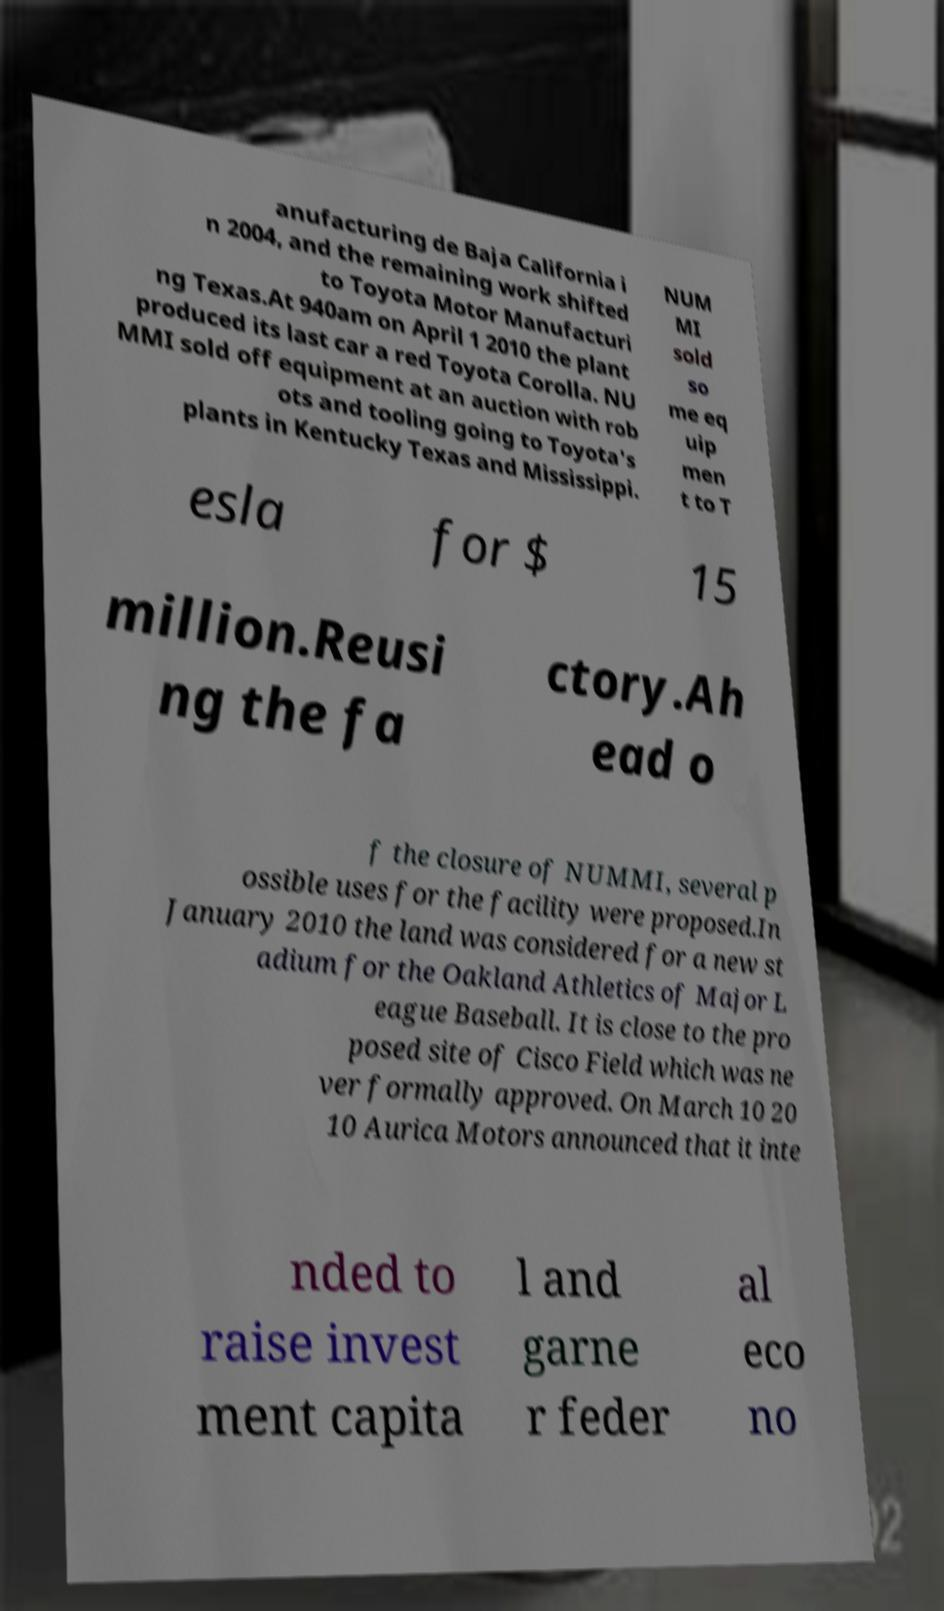Can you accurately transcribe the text from the provided image for me? anufacturing de Baja California i n 2004, and the remaining work shifted to Toyota Motor Manufacturi ng Texas.At 940am on April 1 2010 the plant produced its last car a red Toyota Corolla. NU MMI sold off equipment at an auction with rob ots and tooling going to Toyota's plants in Kentucky Texas and Mississippi. NUM MI sold so me eq uip men t to T esla for $ 15 million.Reusi ng the fa ctory.Ah ead o f the closure of NUMMI, several p ossible uses for the facility were proposed.In January 2010 the land was considered for a new st adium for the Oakland Athletics of Major L eague Baseball. It is close to the pro posed site of Cisco Field which was ne ver formally approved. On March 10 20 10 Aurica Motors announced that it inte nded to raise invest ment capita l and garne r feder al eco no 